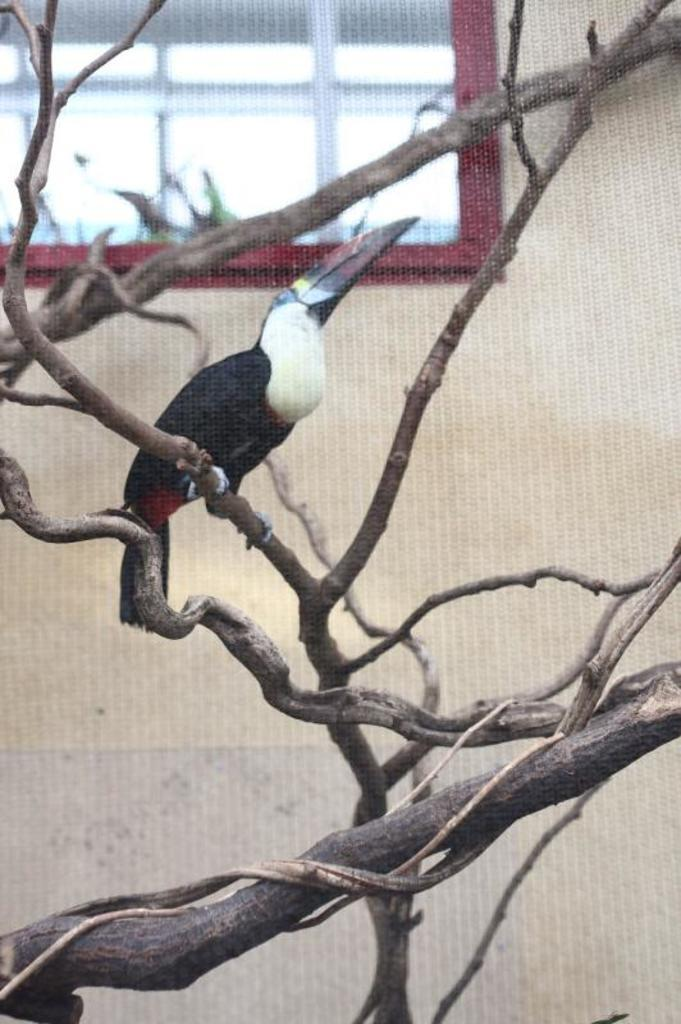What type of animal can be seen in the image? There is a bird in the image. Where is the bird located? The bird is on a branch of a tree. What can be seen in the background of the image? There is a window and a wall visible in the background of the image. What type of chalk is the bird using to draw on the wall in the image? There is no chalk or drawing activity present in the image; it features a bird on a tree branch. How many women are visible in the image? There are no women present in the image. 